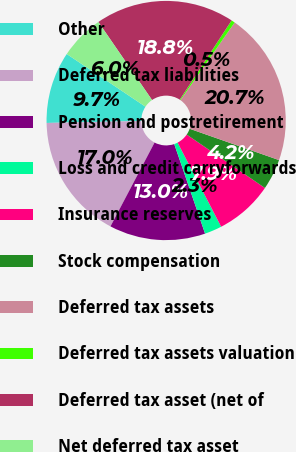Convert chart. <chart><loc_0><loc_0><loc_500><loc_500><pie_chart><fcel>Other<fcel>Deferred tax liabilities<fcel>Pension and postretirement<fcel>Loss and credit carryforwards<fcel>Insurance reserves<fcel>Stock compensation<fcel>Deferred tax assets<fcel>Deferred tax assets valuation<fcel>Deferred tax asset (net of<fcel>Net deferred tax asset<nl><fcel>9.71%<fcel>16.97%<fcel>12.98%<fcel>2.33%<fcel>7.86%<fcel>4.17%<fcel>20.66%<fcel>0.49%<fcel>18.81%<fcel>6.02%<nl></chart> 